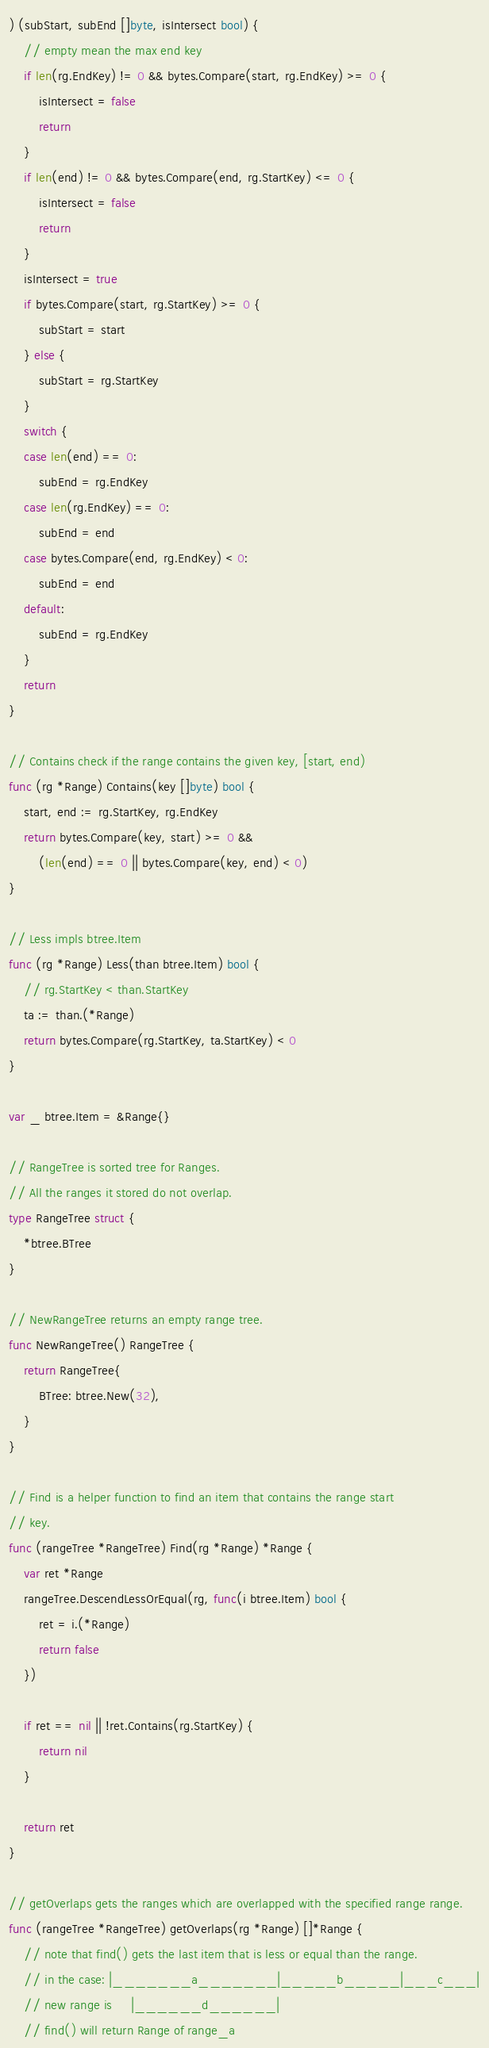<code> <loc_0><loc_0><loc_500><loc_500><_Go_>) (subStart, subEnd []byte, isIntersect bool) {
	// empty mean the max end key
	if len(rg.EndKey) != 0 && bytes.Compare(start, rg.EndKey) >= 0 {
		isIntersect = false
		return
	}
	if len(end) != 0 && bytes.Compare(end, rg.StartKey) <= 0 {
		isIntersect = false
		return
	}
	isIntersect = true
	if bytes.Compare(start, rg.StartKey) >= 0 {
		subStart = start
	} else {
		subStart = rg.StartKey
	}
	switch {
	case len(end) == 0:
		subEnd = rg.EndKey
	case len(rg.EndKey) == 0:
		subEnd = end
	case bytes.Compare(end, rg.EndKey) < 0:
		subEnd = end
	default:
		subEnd = rg.EndKey
	}
	return
}

// Contains check if the range contains the given key, [start, end)
func (rg *Range) Contains(key []byte) bool {
	start, end := rg.StartKey, rg.EndKey
	return bytes.Compare(key, start) >= 0 &&
		(len(end) == 0 || bytes.Compare(key, end) < 0)
}

// Less impls btree.Item
func (rg *Range) Less(than btree.Item) bool {
	// rg.StartKey < than.StartKey
	ta := than.(*Range)
	return bytes.Compare(rg.StartKey, ta.StartKey) < 0
}

var _ btree.Item = &Range{}

// RangeTree is sorted tree for Ranges.
// All the ranges it stored do not overlap.
type RangeTree struct {
	*btree.BTree
}

// NewRangeTree returns an empty range tree.
func NewRangeTree() RangeTree {
	return RangeTree{
		BTree: btree.New(32),
	}
}

// Find is a helper function to find an item that contains the range start
// key.
func (rangeTree *RangeTree) Find(rg *Range) *Range {
	var ret *Range
	rangeTree.DescendLessOrEqual(rg, func(i btree.Item) bool {
		ret = i.(*Range)
		return false
	})

	if ret == nil || !ret.Contains(rg.StartKey) {
		return nil
	}

	return ret
}

// getOverlaps gets the ranges which are overlapped with the specified range range.
func (rangeTree *RangeTree) getOverlaps(rg *Range) []*Range {
	// note that find() gets the last item that is less or equal than the range.
	// in the case: |_______a_______|_____b_____|___c___|
	// new range is     |______d______|
	// find() will return Range of range_a</code> 